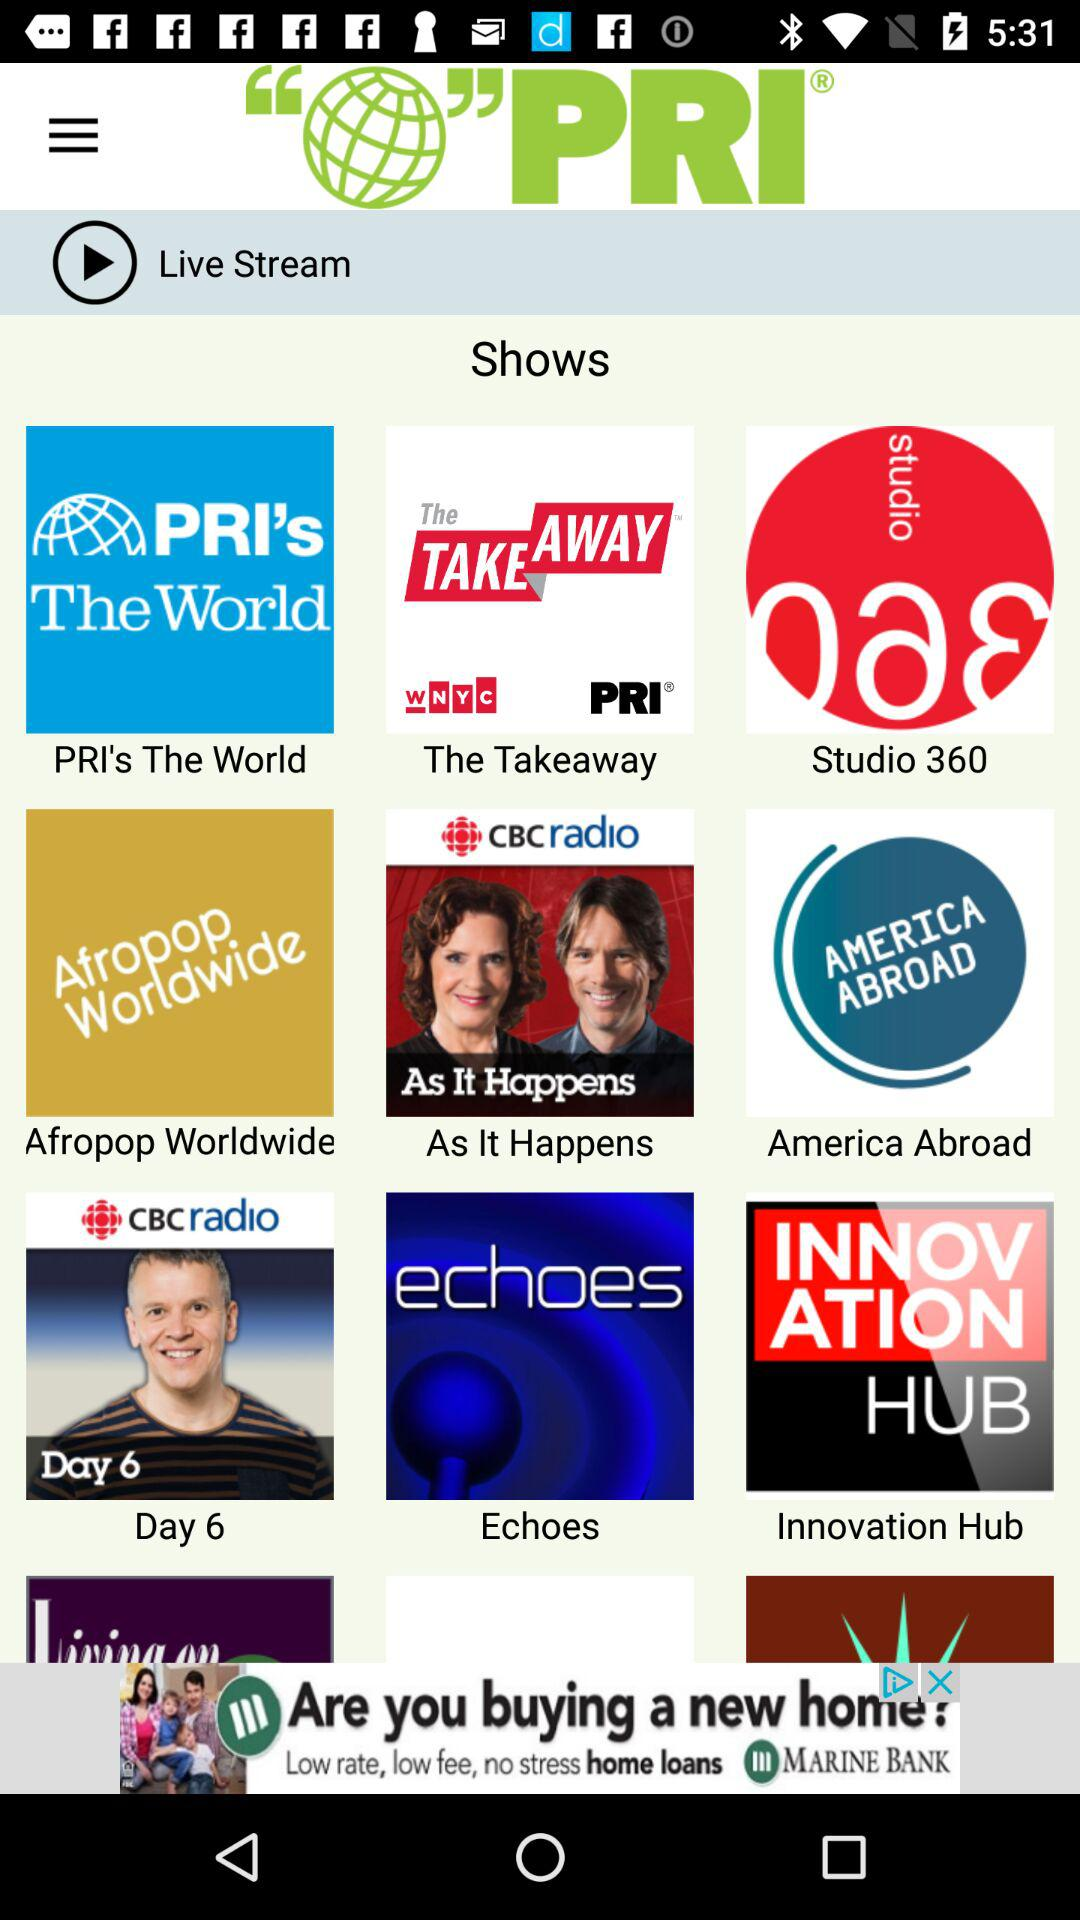What is the application name? The application name is "PRI". 